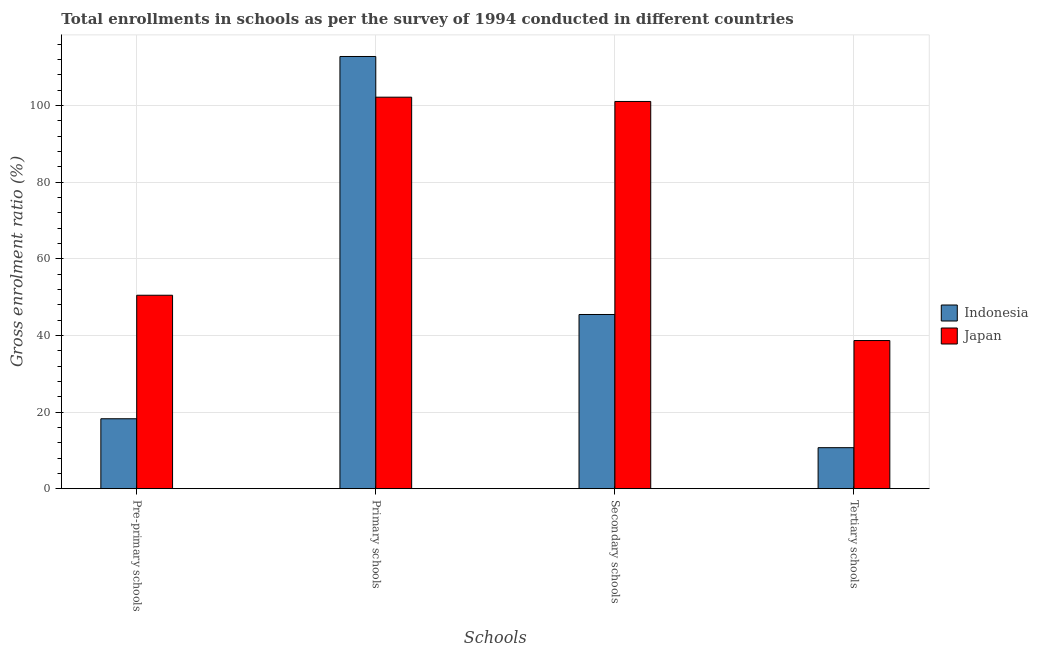How many groups of bars are there?
Your response must be concise. 4. Are the number of bars per tick equal to the number of legend labels?
Provide a succinct answer. Yes. What is the label of the 2nd group of bars from the left?
Offer a terse response. Primary schools. What is the gross enrolment ratio in pre-primary schools in Indonesia?
Offer a terse response. 18.25. Across all countries, what is the maximum gross enrolment ratio in pre-primary schools?
Your answer should be very brief. 50.47. Across all countries, what is the minimum gross enrolment ratio in primary schools?
Ensure brevity in your answer.  102.16. In which country was the gross enrolment ratio in primary schools maximum?
Give a very brief answer. Indonesia. What is the total gross enrolment ratio in primary schools in the graph?
Make the answer very short. 214.94. What is the difference between the gross enrolment ratio in secondary schools in Japan and that in Indonesia?
Ensure brevity in your answer.  55.59. What is the difference between the gross enrolment ratio in tertiary schools in Japan and the gross enrolment ratio in pre-primary schools in Indonesia?
Make the answer very short. 20.41. What is the average gross enrolment ratio in primary schools per country?
Offer a very short reply. 107.47. What is the difference between the gross enrolment ratio in primary schools and gross enrolment ratio in pre-primary schools in Indonesia?
Offer a very short reply. 94.53. What is the ratio of the gross enrolment ratio in tertiary schools in Indonesia to that in Japan?
Your answer should be very brief. 0.28. Is the gross enrolment ratio in primary schools in Indonesia less than that in Japan?
Provide a short and direct response. No. Is the difference between the gross enrolment ratio in pre-primary schools in Indonesia and Japan greater than the difference between the gross enrolment ratio in secondary schools in Indonesia and Japan?
Your response must be concise. Yes. What is the difference between the highest and the second highest gross enrolment ratio in secondary schools?
Keep it short and to the point. 55.59. What is the difference between the highest and the lowest gross enrolment ratio in primary schools?
Give a very brief answer. 10.62. In how many countries, is the gross enrolment ratio in tertiary schools greater than the average gross enrolment ratio in tertiary schools taken over all countries?
Provide a succinct answer. 1. Is it the case that in every country, the sum of the gross enrolment ratio in pre-primary schools and gross enrolment ratio in tertiary schools is greater than the sum of gross enrolment ratio in primary schools and gross enrolment ratio in secondary schools?
Give a very brief answer. No. What does the 1st bar from the left in Primary schools represents?
Ensure brevity in your answer.  Indonesia. Is it the case that in every country, the sum of the gross enrolment ratio in pre-primary schools and gross enrolment ratio in primary schools is greater than the gross enrolment ratio in secondary schools?
Your response must be concise. Yes. How many bars are there?
Provide a short and direct response. 8. How many countries are there in the graph?
Provide a succinct answer. 2. Does the graph contain any zero values?
Give a very brief answer. No. How many legend labels are there?
Your response must be concise. 2. What is the title of the graph?
Your answer should be very brief. Total enrollments in schools as per the survey of 1994 conducted in different countries. Does "Turkey" appear as one of the legend labels in the graph?
Your response must be concise. No. What is the label or title of the X-axis?
Make the answer very short. Schools. What is the label or title of the Y-axis?
Your response must be concise. Gross enrolment ratio (%). What is the Gross enrolment ratio (%) in Indonesia in Pre-primary schools?
Your answer should be very brief. 18.25. What is the Gross enrolment ratio (%) of Japan in Pre-primary schools?
Offer a terse response. 50.47. What is the Gross enrolment ratio (%) in Indonesia in Primary schools?
Ensure brevity in your answer.  112.78. What is the Gross enrolment ratio (%) of Japan in Primary schools?
Ensure brevity in your answer.  102.16. What is the Gross enrolment ratio (%) of Indonesia in Secondary schools?
Keep it short and to the point. 45.45. What is the Gross enrolment ratio (%) of Japan in Secondary schools?
Your answer should be very brief. 101.04. What is the Gross enrolment ratio (%) in Indonesia in Tertiary schools?
Provide a succinct answer. 10.7. What is the Gross enrolment ratio (%) in Japan in Tertiary schools?
Provide a succinct answer. 38.66. Across all Schools, what is the maximum Gross enrolment ratio (%) of Indonesia?
Make the answer very short. 112.78. Across all Schools, what is the maximum Gross enrolment ratio (%) of Japan?
Provide a succinct answer. 102.16. Across all Schools, what is the minimum Gross enrolment ratio (%) of Indonesia?
Make the answer very short. 10.7. Across all Schools, what is the minimum Gross enrolment ratio (%) of Japan?
Your answer should be compact. 38.66. What is the total Gross enrolment ratio (%) of Indonesia in the graph?
Make the answer very short. 187.17. What is the total Gross enrolment ratio (%) of Japan in the graph?
Ensure brevity in your answer.  292.33. What is the difference between the Gross enrolment ratio (%) in Indonesia in Pre-primary schools and that in Primary schools?
Give a very brief answer. -94.53. What is the difference between the Gross enrolment ratio (%) of Japan in Pre-primary schools and that in Primary schools?
Offer a terse response. -51.69. What is the difference between the Gross enrolment ratio (%) in Indonesia in Pre-primary schools and that in Secondary schools?
Make the answer very short. -27.21. What is the difference between the Gross enrolment ratio (%) of Japan in Pre-primary schools and that in Secondary schools?
Your response must be concise. -50.57. What is the difference between the Gross enrolment ratio (%) of Indonesia in Pre-primary schools and that in Tertiary schools?
Your answer should be very brief. 7.55. What is the difference between the Gross enrolment ratio (%) in Japan in Pre-primary schools and that in Tertiary schools?
Make the answer very short. 11.82. What is the difference between the Gross enrolment ratio (%) of Indonesia in Primary schools and that in Secondary schools?
Offer a terse response. 67.32. What is the difference between the Gross enrolment ratio (%) of Japan in Primary schools and that in Secondary schools?
Your answer should be compact. 1.12. What is the difference between the Gross enrolment ratio (%) in Indonesia in Primary schools and that in Tertiary schools?
Your answer should be compact. 102.08. What is the difference between the Gross enrolment ratio (%) in Japan in Primary schools and that in Tertiary schools?
Offer a terse response. 63.5. What is the difference between the Gross enrolment ratio (%) of Indonesia in Secondary schools and that in Tertiary schools?
Provide a short and direct response. 34.76. What is the difference between the Gross enrolment ratio (%) of Japan in Secondary schools and that in Tertiary schools?
Provide a short and direct response. 62.39. What is the difference between the Gross enrolment ratio (%) in Indonesia in Pre-primary schools and the Gross enrolment ratio (%) in Japan in Primary schools?
Offer a very short reply. -83.91. What is the difference between the Gross enrolment ratio (%) in Indonesia in Pre-primary schools and the Gross enrolment ratio (%) in Japan in Secondary schools?
Your response must be concise. -82.8. What is the difference between the Gross enrolment ratio (%) in Indonesia in Pre-primary schools and the Gross enrolment ratio (%) in Japan in Tertiary schools?
Ensure brevity in your answer.  -20.41. What is the difference between the Gross enrolment ratio (%) in Indonesia in Primary schools and the Gross enrolment ratio (%) in Japan in Secondary schools?
Ensure brevity in your answer.  11.73. What is the difference between the Gross enrolment ratio (%) in Indonesia in Primary schools and the Gross enrolment ratio (%) in Japan in Tertiary schools?
Your response must be concise. 74.12. What is the difference between the Gross enrolment ratio (%) of Indonesia in Secondary schools and the Gross enrolment ratio (%) of Japan in Tertiary schools?
Provide a succinct answer. 6.8. What is the average Gross enrolment ratio (%) of Indonesia per Schools?
Offer a terse response. 46.79. What is the average Gross enrolment ratio (%) in Japan per Schools?
Make the answer very short. 73.08. What is the difference between the Gross enrolment ratio (%) of Indonesia and Gross enrolment ratio (%) of Japan in Pre-primary schools?
Ensure brevity in your answer.  -32.23. What is the difference between the Gross enrolment ratio (%) of Indonesia and Gross enrolment ratio (%) of Japan in Primary schools?
Give a very brief answer. 10.62. What is the difference between the Gross enrolment ratio (%) of Indonesia and Gross enrolment ratio (%) of Japan in Secondary schools?
Offer a terse response. -55.59. What is the difference between the Gross enrolment ratio (%) of Indonesia and Gross enrolment ratio (%) of Japan in Tertiary schools?
Offer a terse response. -27.96. What is the ratio of the Gross enrolment ratio (%) of Indonesia in Pre-primary schools to that in Primary schools?
Give a very brief answer. 0.16. What is the ratio of the Gross enrolment ratio (%) in Japan in Pre-primary schools to that in Primary schools?
Your answer should be very brief. 0.49. What is the ratio of the Gross enrolment ratio (%) in Indonesia in Pre-primary schools to that in Secondary schools?
Provide a short and direct response. 0.4. What is the ratio of the Gross enrolment ratio (%) of Japan in Pre-primary schools to that in Secondary schools?
Your response must be concise. 0.5. What is the ratio of the Gross enrolment ratio (%) of Indonesia in Pre-primary schools to that in Tertiary schools?
Your answer should be compact. 1.71. What is the ratio of the Gross enrolment ratio (%) of Japan in Pre-primary schools to that in Tertiary schools?
Keep it short and to the point. 1.31. What is the ratio of the Gross enrolment ratio (%) of Indonesia in Primary schools to that in Secondary schools?
Your answer should be very brief. 2.48. What is the ratio of the Gross enrolment ratio (%) in Indonesia in Primary schools to that in Tertiary schools?
Provide a short and direct response. 10.54. What is the ratio of the Gross enrolment ratio (%) in Japan in Primary schools to that in Tertiary schools?
Offer a very short reply. 2.64. What is the ratio of the Gross enrolment ratio (%) of Indonesia in Secondary schools to that in Tertiary schools?
Provide a short and direct response. 4.25. What is the ratio of the Gross enrolment ratio (%) of Japan in Secondary schools to that in Tertiary schools?
Ensure brevity in your answer.  2.61. What is the difference between the highest and the second highest Gross enrolment ratio (%) in Indonesia?
Your answer should be very brief. 67.32. What is the difference between the highest and the second highest Gross enrolment ratio (%) of Japan?
Keep it short and to the point. 1.12. What is the difference between the highest and the lowest Gross enrolment ratio (%) of Indonesia?
Ensure brevity in your answer.  102.08. What is the difference between the highest and the lowest Gross enrolment ratio (%) of Japan?
Your response must be concise. 63.5. 